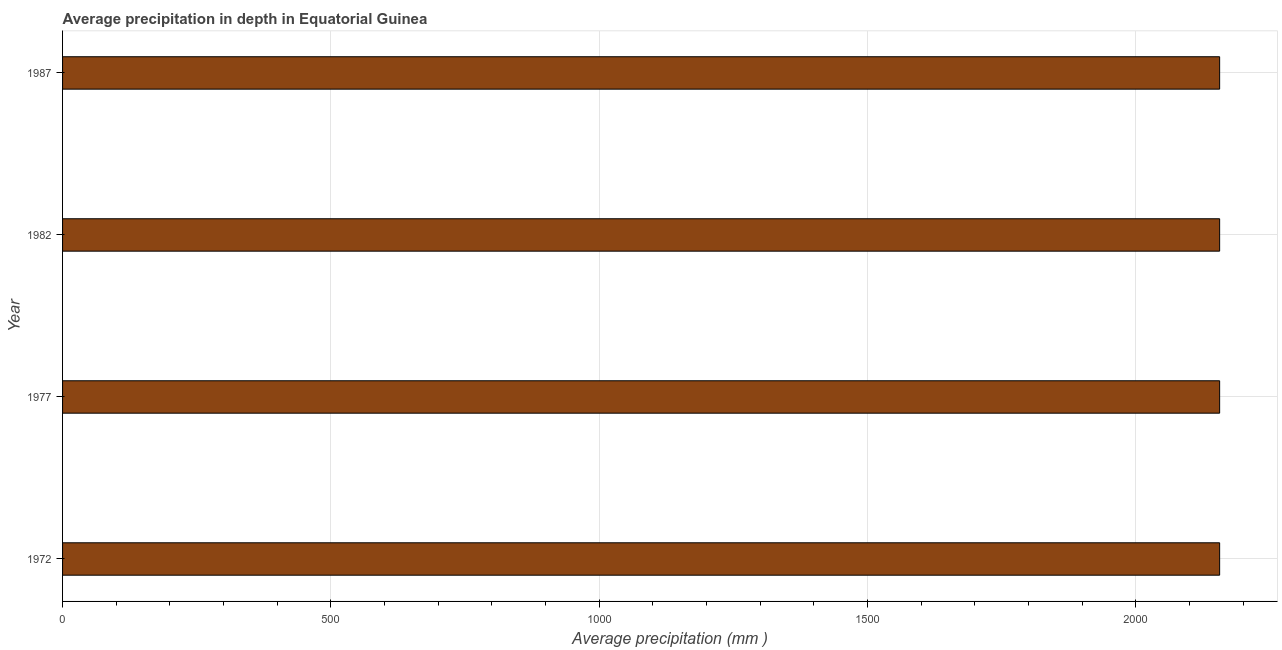Does the graph contain grids?
Your response must be concise. Yes. What is the title of the graph?
Your response must be concise. Average precipitation in depth in Equatorial Guinea. What is the label or title of the X-axis?
Your answer should be very brief. Average precipitation (mm ). What is the label or title of the Y-axis?
Provide a succinct answer. Year. What is the average precipitation in depth in 1972?
Provide a succinct answer. 2156. Across all years, what is the maximum average precipitation in depth?
Give a very brief answer. 2156. Across all years, what is the minimum average precipitation in depth?
Your answer should be very brief. 2156. In which year was the average precipitation in depth minimum?
Ensure brevity in your answer.  1972. What is the sum of the average precipitation in depth?
Your answer should be compact. 8624. What is the average average precipitation in depth per year?
Your answer should be very brief. 2156. What is the median average precipitation in depth?
Provide a short and direct response. 2156. Do a majority of the years between 1987 and 1982 (inclusive) have average precipitation in depth greater than 2000 mm?
Provide a succinct answer. No. Is the average precipitation in depth in 1982 less than that in 1987?
Your answer should be compact. No. Is the difference between the average precipitation in depth in 1977 and 1987 greater than the difference between any two years?
Offer a very short reply. Yes. What is the difference between the highest and the second highest average precipitation in depth?
Make the answer very short. 0. Is the sum of the average precipitation in depth in 1982 and 1987 greater than the maximum average precipitation in depth across all years?
Make the answer very short. Yes. What is the difference between the highest and the lowest average precipitation in depth?
Give a very brief answer. 0. Are all the bars in the graph horizontal?
Make the answer very short. Yes. How many years are there in the graph?
Ensure brevity in your answer.  4. Are the values on the major ticks of X-axis written in scientific E-notation?
Your response must be concise. No. What is the Average precipitation (mm ) of 1972?
Your answer should be very brief. 2156. What is the Average precipitation (mm ) in 1977?
Provide a short and direct response. 2156. What is the Average precipitation (mm ) in 1982?
Keep it short and to the point. 2156. What is the Average precipitation (mm ) in 1987?
Provide a short and direct response. 2156. What is the difference between the Average precipitation (mm ) in 1972 and 1977?
Offer a terse response. 0. What is the difference between the Average precipitation (mm ) in 1972 and 1982?
Provide a short and direct response. 0. What is the difference between the Average precipitation (mm ) in 1977 and 1982?
Your answer should be very brief. 0. What is the difference between the Average precipitation (mm ) in 1977 and 1987?
Provide a short and direct response. 0. What is the ratio of the Average precipitation (mm ) in 1972 to that in 1982?
Keep it short and to the point. 1. What is the ratio of the Average precipitation (mm ) in 1982 to that in 1987?
Offer a terse response. 1. 